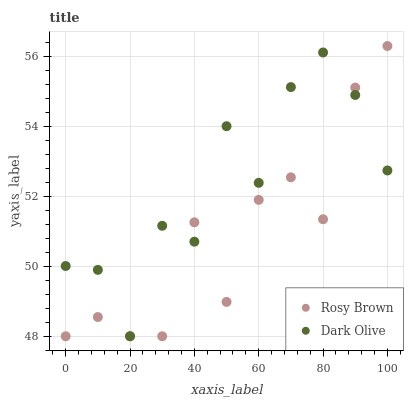Does Rosy Brown have the minimum area under the curve?
Answer yes or no. Yes. Does Dark Olive have the maximum area under the curve?
Answer yes or no. Yes. Does Rosy Brown have the maximum area under the curve?
Answer yes or no. No. Is Rosy Brown the smoothest?
Answer yes or no. Yes. Is Dark Olive the roughest?
Answer yes or no. Yes. Is Rosy Brown the roughest?
Answer yes or no. No. Does Dark Olive have the lowest value?
Answer yes or no. Yes. Does Rosy Brown have the highest value?
Answer yes or no. Yes. Does Dark Olive intersect Rosy Brown?
Answer yes or no. Yes. Is Dark Olive less than Rosy Brown?
Answer yes or no. No. Is Dark Olive greater than Rosy Brown?
Answer yes or no. No. 